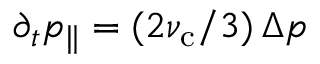Convert formula to latex. <formula><loc_0><loc_0><loc_500><loc_500>\partial _ { t } p _ { \| } = ( 2 \nu _ { c } / 3 ) \, \Delta p</formula> 